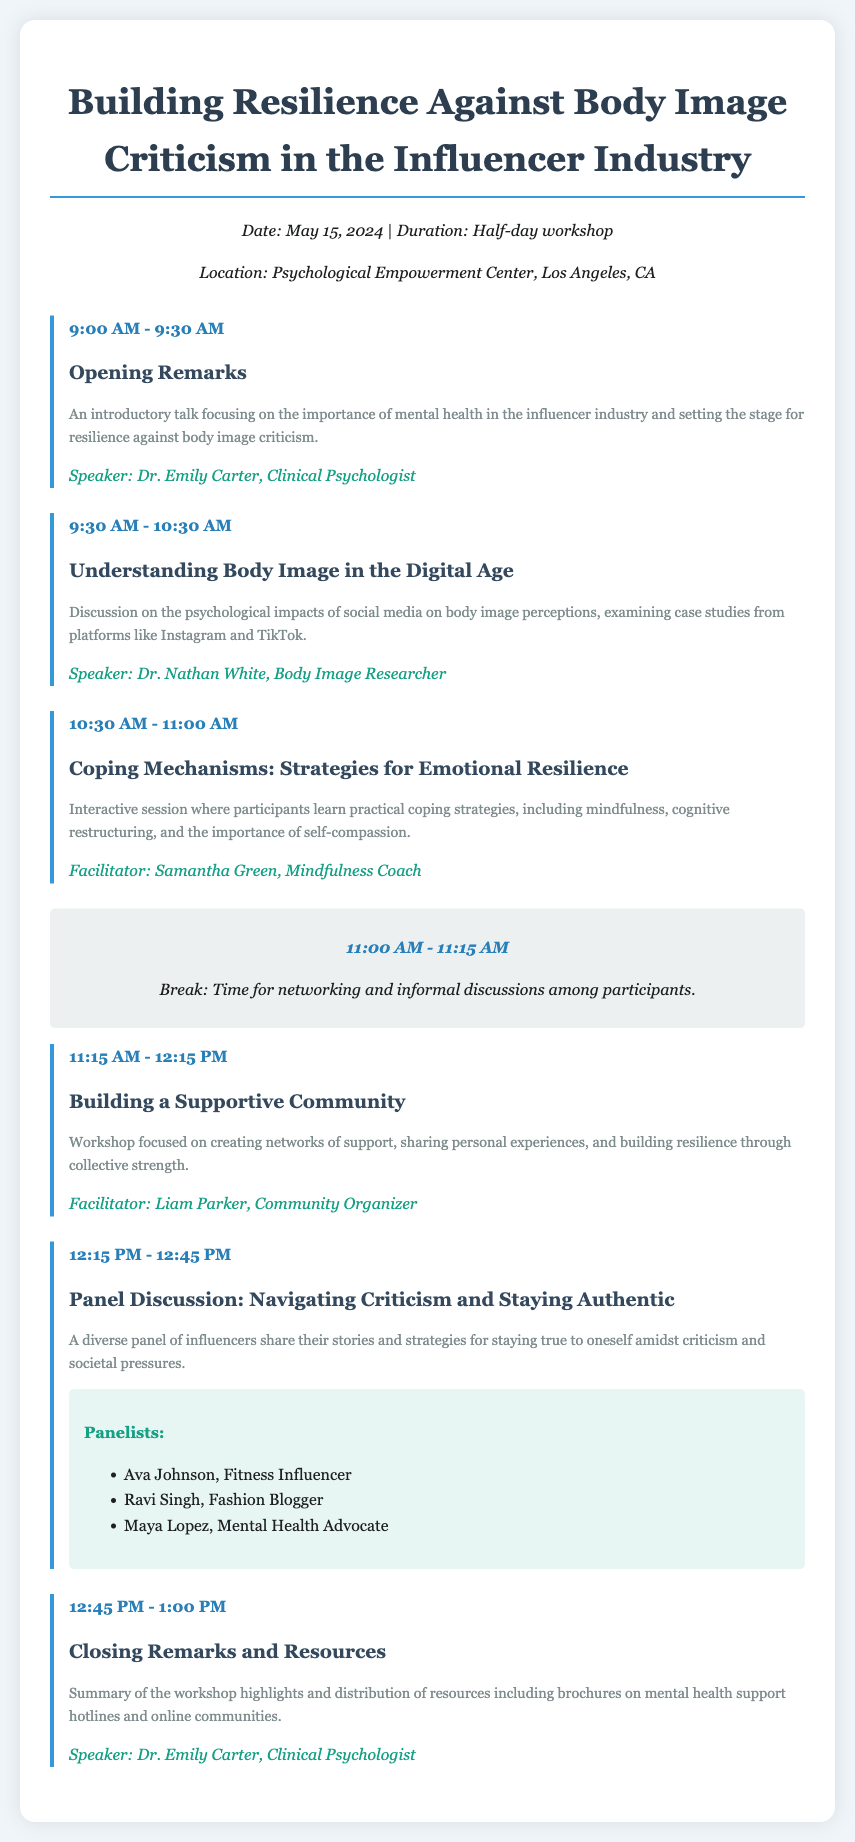What is the date of the workshop? The date of the workshop is clearly stated in the document as May 15, 2024.
Answer: May 15, 2024 Who is the speaker for the opening remarks? The document lists Dr. Emily Carter as the speaker for the opening remarks.
Answer: Dr. Emily Carter What is the title of the session at 9:30 AM? The session scheduled at 9:30 AM is titled "Understanding Body Image in the Digital Age."
Answer: Understanding Body Image in the Digital Age How long is the break scheduled for? The scheduled break is from 11:00 AM to 11:15 AM, which is 15 minutes long.
Answer: 15 minutes What are participants expected to learn in the coping mechanisms session? The session focuses on learning practical coping strategies, including mindfulness, cognitive restructuring, and self-compassion.
Answer: Practical coping strategies Who are the panelists in the panel discussion? The document lists Ava Johnson, Ravi Singh, and Maya Lopez as the panelists.
Answer: Ava Johnson, Ravi Singh, Maya Lopez What is the location of the workshop? The workshop will take place at the Psychological Empowerment Center, Los Angeles, CA.
Answer: Psychological Empowerment Center, Los Angeles, CA What is the focus of the session titled "Building a Supportive Community"? This session focuses on creating networks of support, sharing personal experiences, and building resilience.
Answer: Creating networks of support 